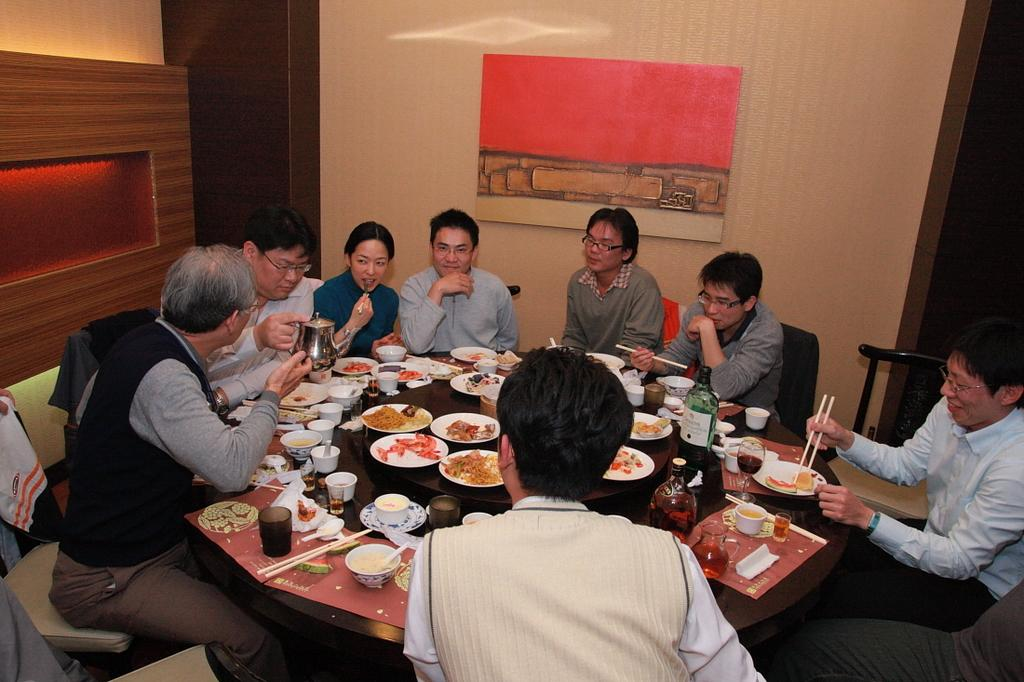How many people are sitting on the chair in the image? There is a group of persons sitting on a chair in the image. What is on the table in the image? There are plates, food, and glasses on the table in the image. What can be seen in the background of the image? There is a wooden wall in the background of the image. How many songs can be heard playing in the background of the image? There is no indication of any songs playing in the background of the image. What type of egg is visible on the table in the image? There is no egg visible on the table in the image. 